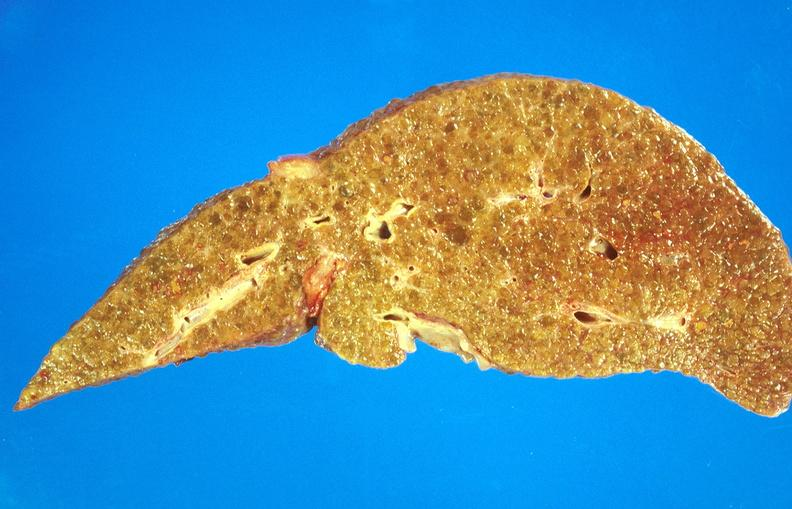what is present?
Answer the question using a single word or phrase. Liver 